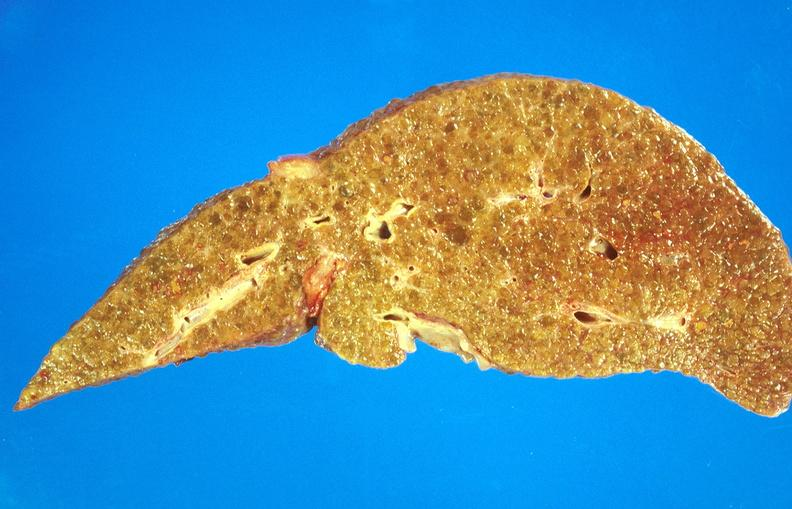what is present?
Answer the question using a single word or phrase. Liver 